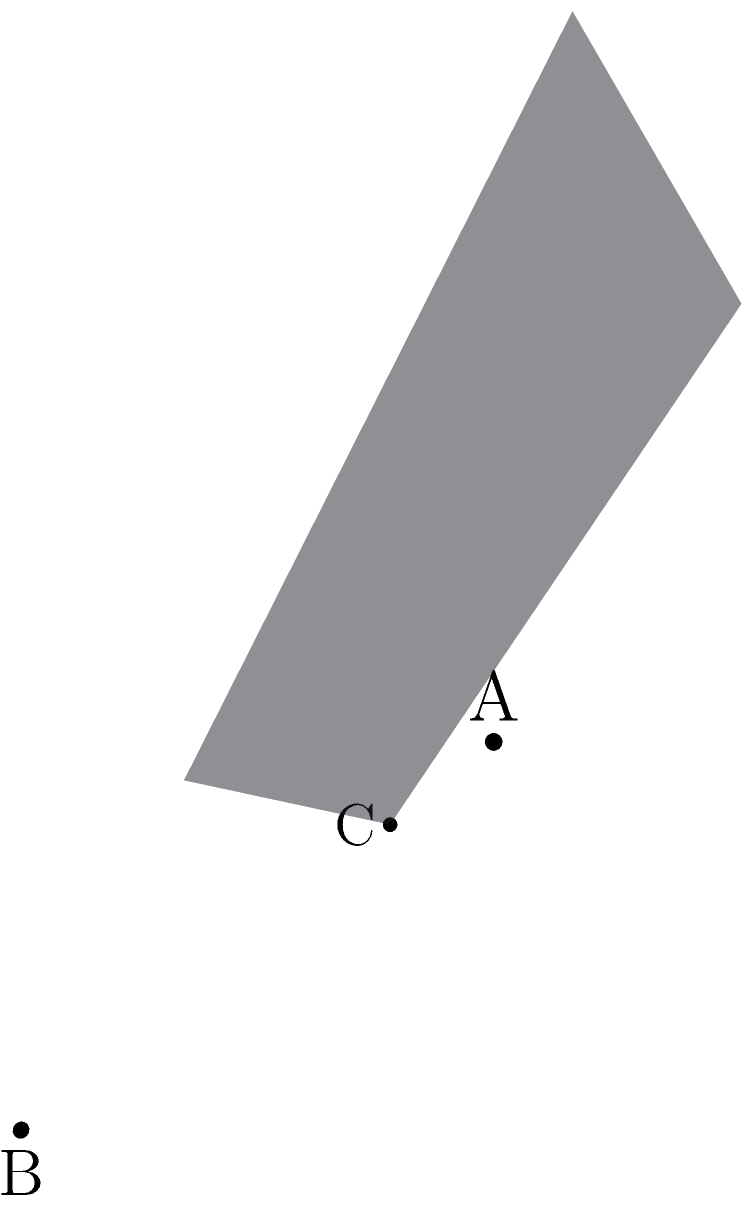En una escena 3D, necesitas crear un plano para colocar objetos. Se te dan tres puntos en el espacio: $A(1,2,3)$, $B(2,0,1)$, y $C(0,1,2)$. Encuentra la ecuación del plano que pasa por estos tres puntos en la forma general $Ax + By + Cz + D = 0$. Para encontrar la ecuación del plano, seguiremos estos pasos:

1) Calculamos dos vectores en el plano:
   $\vec{AB} = B - A = (1,-2,-2)$
   $\vec{AC} = C - A = (-1,-1,-1)$

2) El vector normal al plano es el producto cruz de estos vectores:
   $\vec{n} = \vec{AB} \times \vec{AC} = \begin{vmatrix} 
   i & j & k \\
   1 & -2 & -2 \\
   -1 & -1 & -1
   \end{vmatrix} = (-2+2)i + (-2+1)j + (-1+2)k = (0,-1,1)$

3) La ecuación del plano es $\vec{n} \cdot (x,y,z) = \vec{n} \cdot A$:
   $0(x-1) + (-1)(y-2) + 1(z-3) = 0$

4) Simplificando:
   $-y + z + 1 = 0$

5) En la forma general $Ax + By + Cz + D = 0$:
   $0x - 1y + 1z + 1 = 0$
Answer: $-y + z + 1 = 0$ 